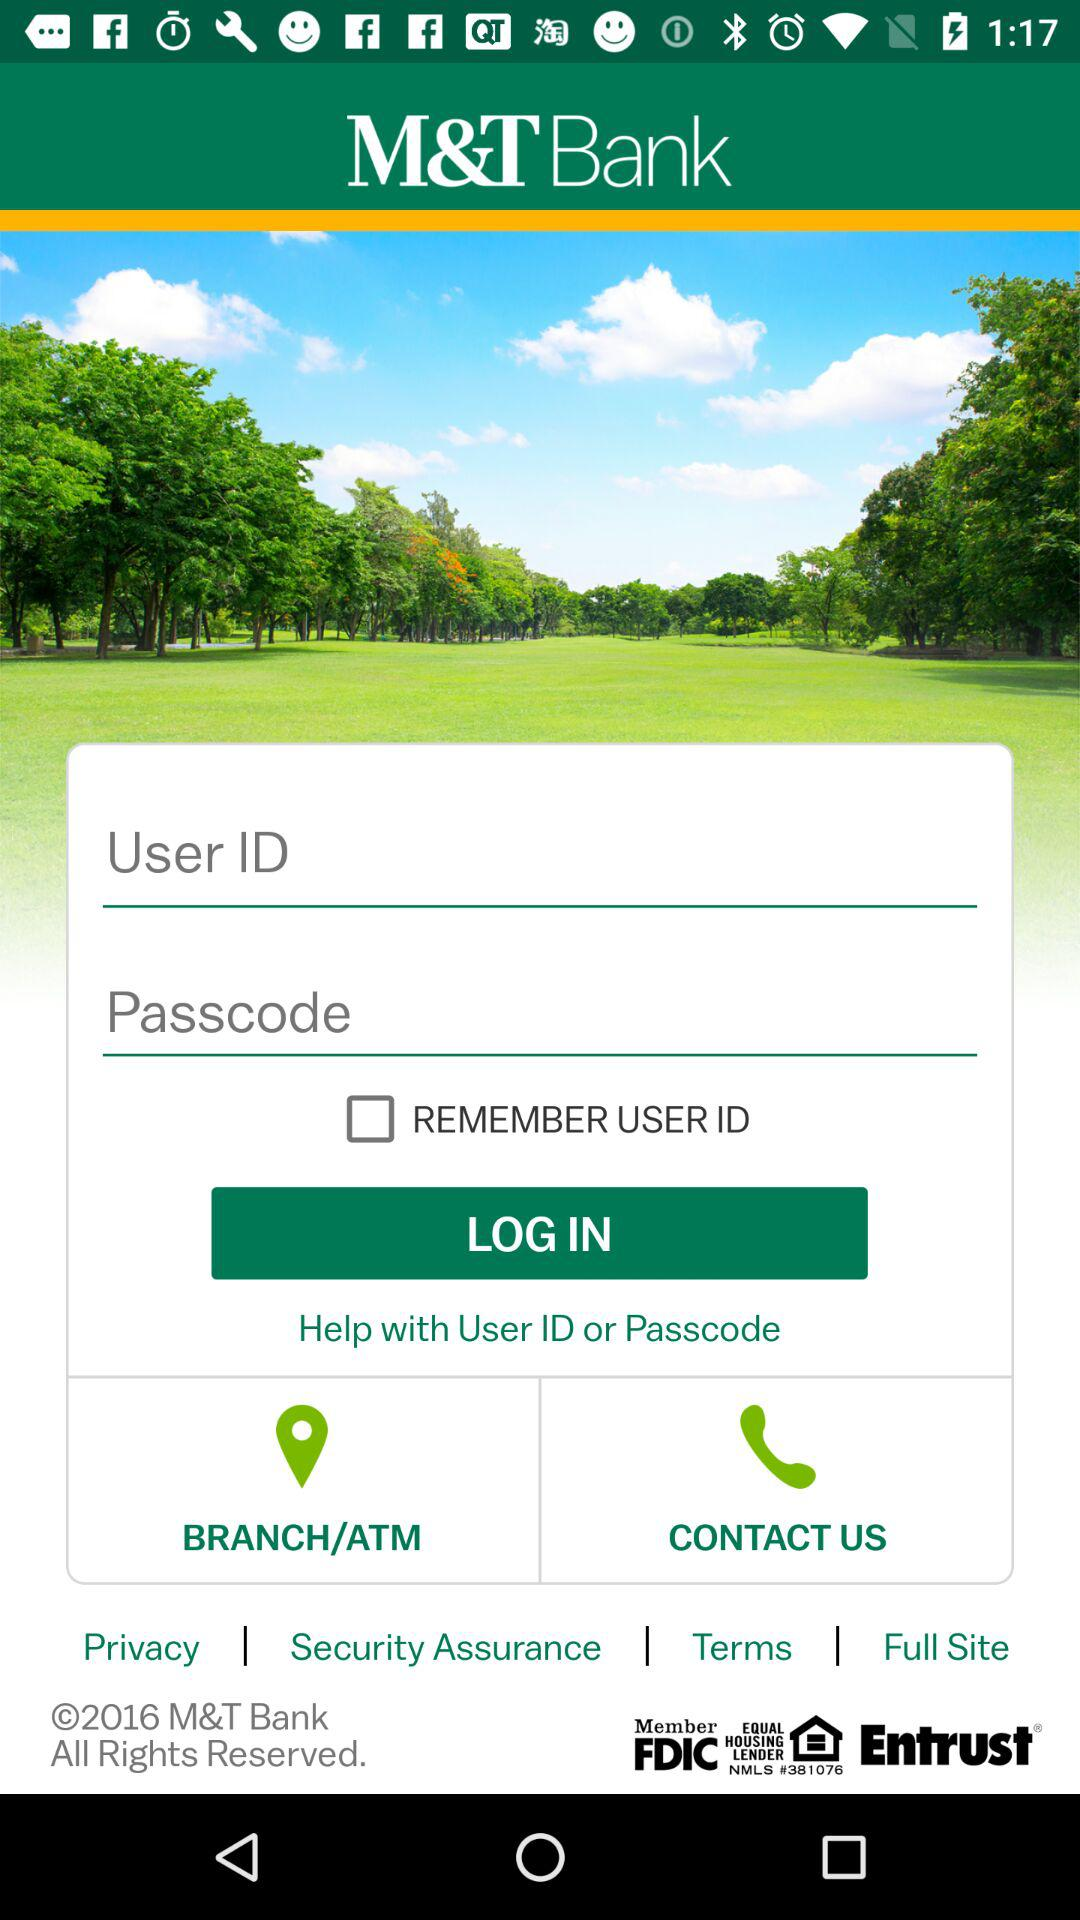What is the application name? The application name is "M&T Bank". 